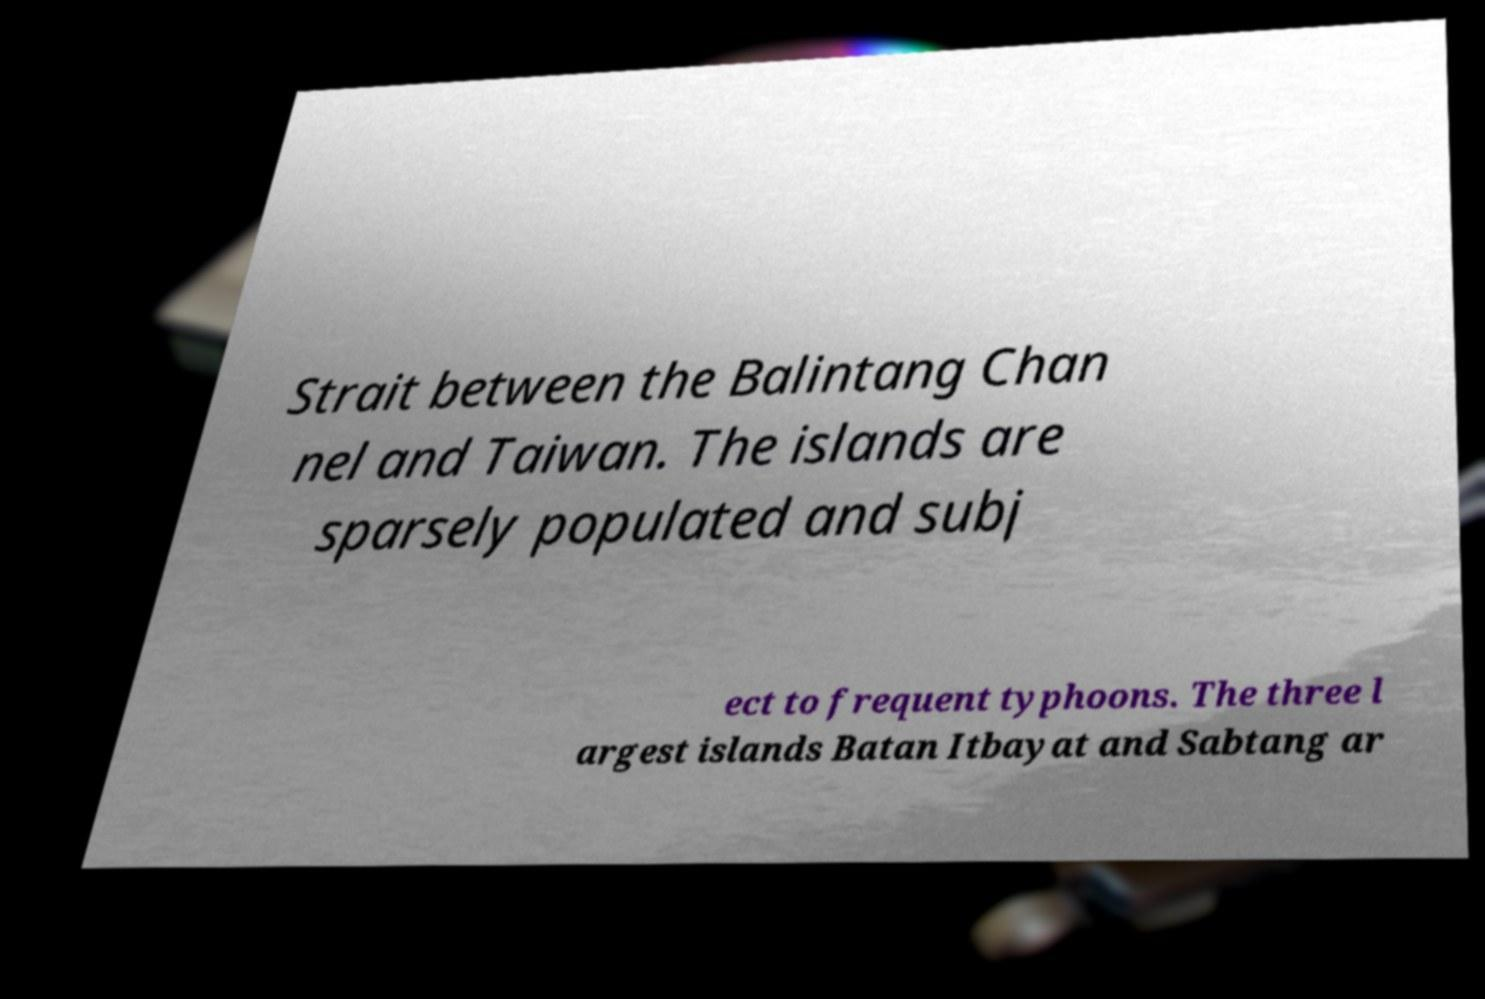Can you read and provide the text displayed in the image?This photo seems to have some interesting text. Can you extract and type it out for me? Strait between the Balintang Chan nel and Taiwan. The islands are sparsely populated and subj ect to frequent typhoons. The three l argest islands Batan Itbayat and Sabtang ar 